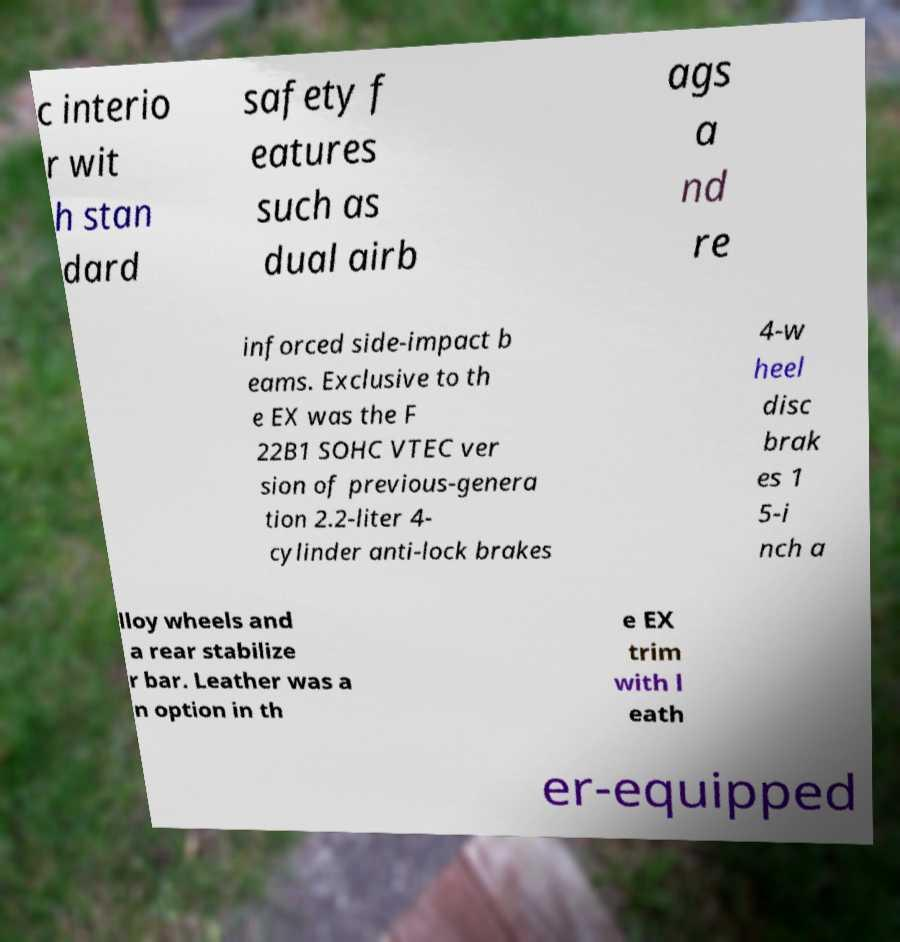For documentation purposes, I need the text within this image transcribed. Could you provide that? c interio r wit h stan dard safety f eatures such as dual airb ags a nd re inforced side-impact b eams. Exclusive to th e EX was the F 22B1 SOHC VTEC ver sion of previous-genera tion 2.2-liter 4- cylinder anti-lock brakes 4-w heel disc brak es 1 5-i nch a lloy wheels and a rear stabilize r bar. Leather was a n option in th e EX trim with l eath er-equipped 